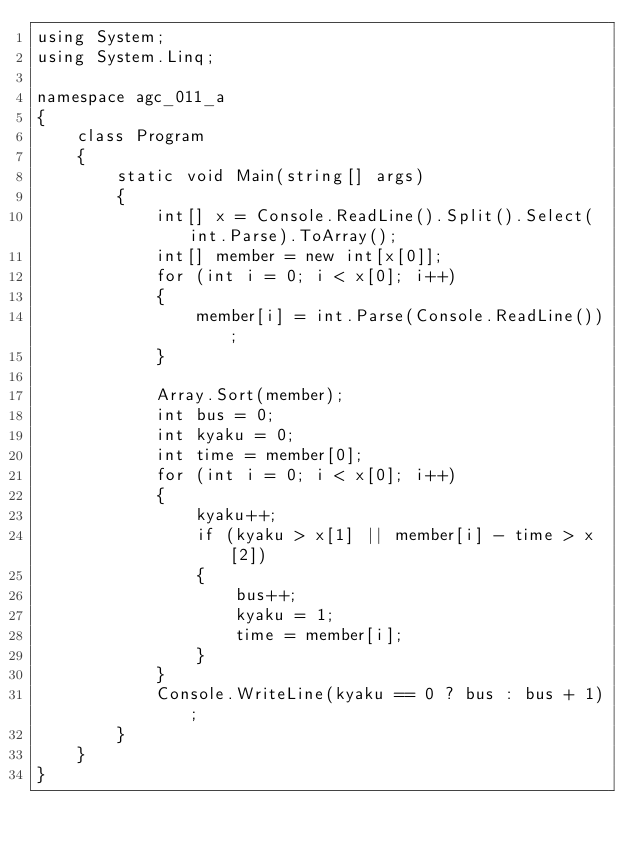Convert code to text. <code><loc_0><loc_0><loc_500><loc_500><_C#_>using System;
using System.Linq;

namespace agc_011_a
{
    class Program
    {
        static void Main(string[] args)
        {
            int[] x = Console.ReadLine().Split().Select(int.Parse).ToArray();
            int[] member = new int[x[0]];
            for (int i = 0; i < x[0]; i++)
            {
                member[i] = int.Parse(Console.ReadLine());
            }
          
            Array.Sort(member);
            int bus = 0;
            int kyaku = 0;
            int time = member[0];
            for (int i = 0; i < x[0]; i++)
            {
                kyaku++;
                if (kyaku > x[1] || member[i] - time > x[2])
                {
                    bus++;
                    kyaku = 1;
                    time = member[i];
                }
            }
            Console.WriteLine(kyaku == 0 ? bus : bus + 1);
        }
    }
}</code> 